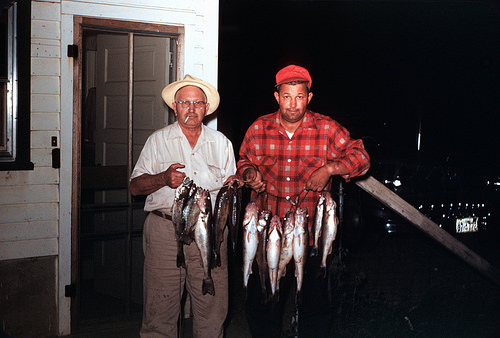<image>
Is the fish to the left of the men? Yes. From this viewpoint, the fish is positioned to the left side relative to the men. Where is the fish in relation to the man? Is it behind the man? No. The fish is not behind the man. From this viewpoint, the fish appears to be positioned elsewhere in the scene. 